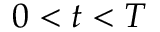<formula> <loc_0><loc_0><loc_500><loc_500>0 < t < T</formula> 